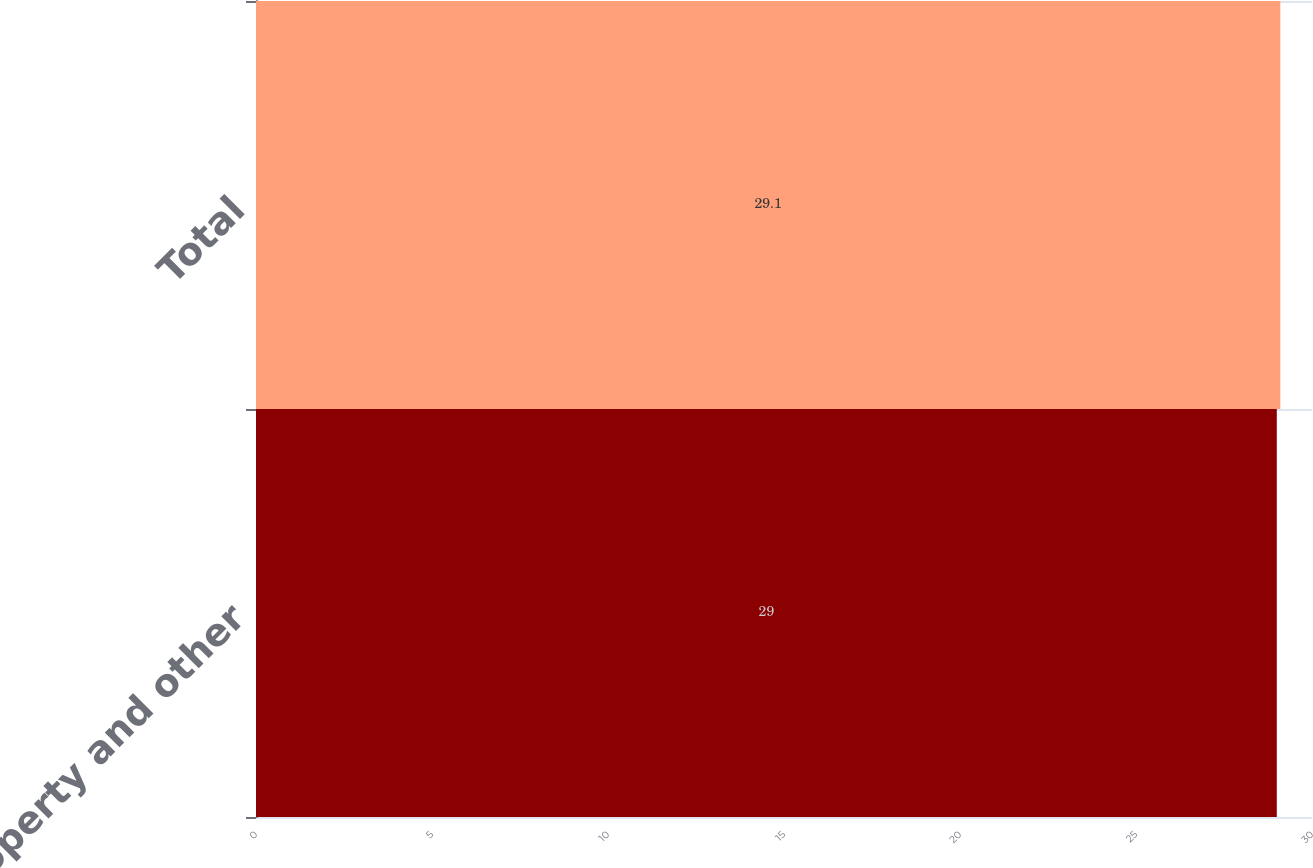Convert chart to OTSL. <chart><loc_0><loc_0><loc_500><loc_500><bar_chart><fcel>Property and other<fcel>Total<nl><fcel>29<fcel>29.1<nl></chart> 